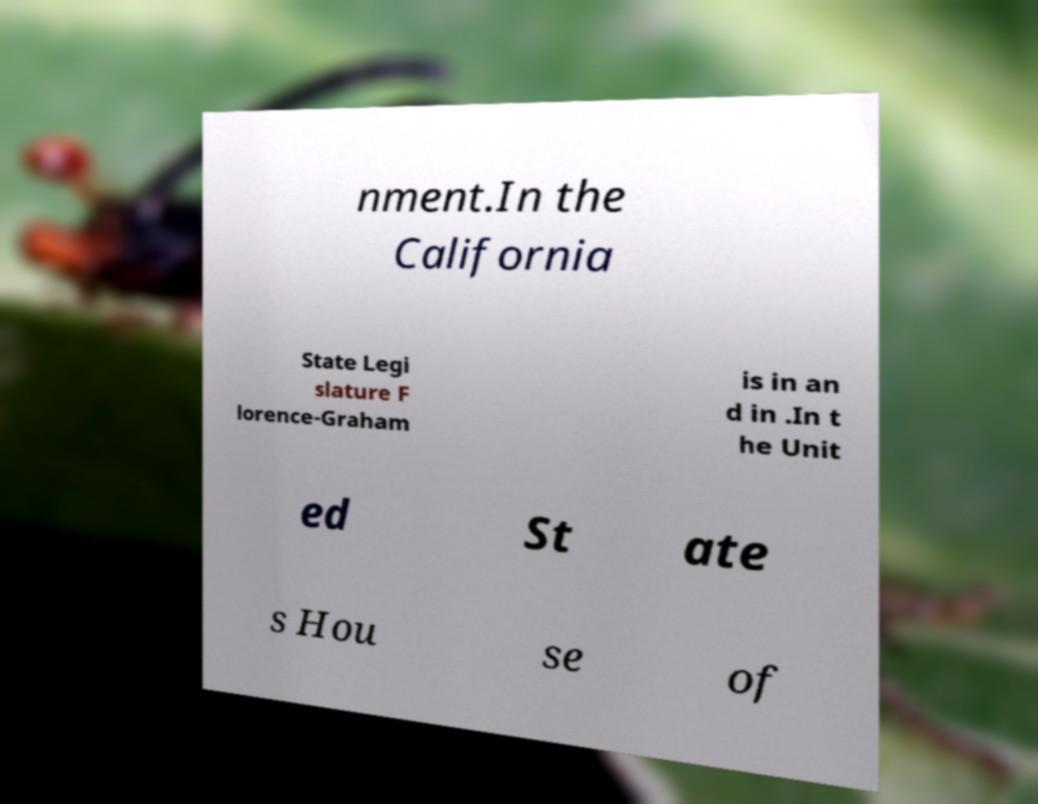What messages or text are displayed in this image? I need them in a readable, typed format. nment.In the California State Legi slature F lorence-Graham is in an d in .In t he Unit ed St ate s Hou se of 